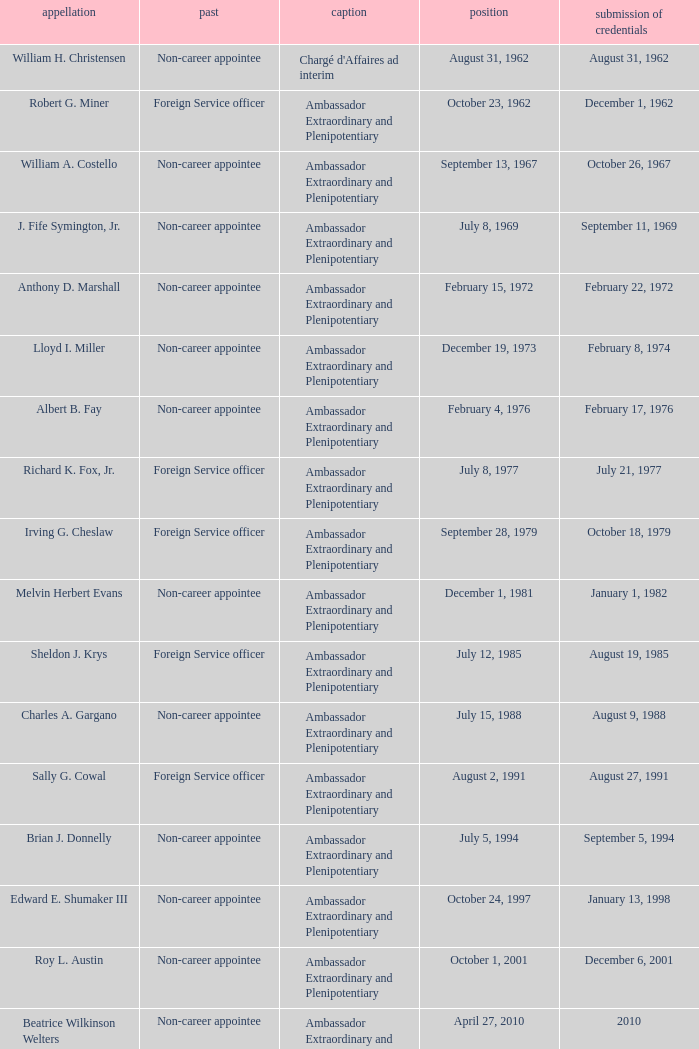What was Anthony D. Marshall's title? Ambassador Extraordinary and Plenipotentiary. 